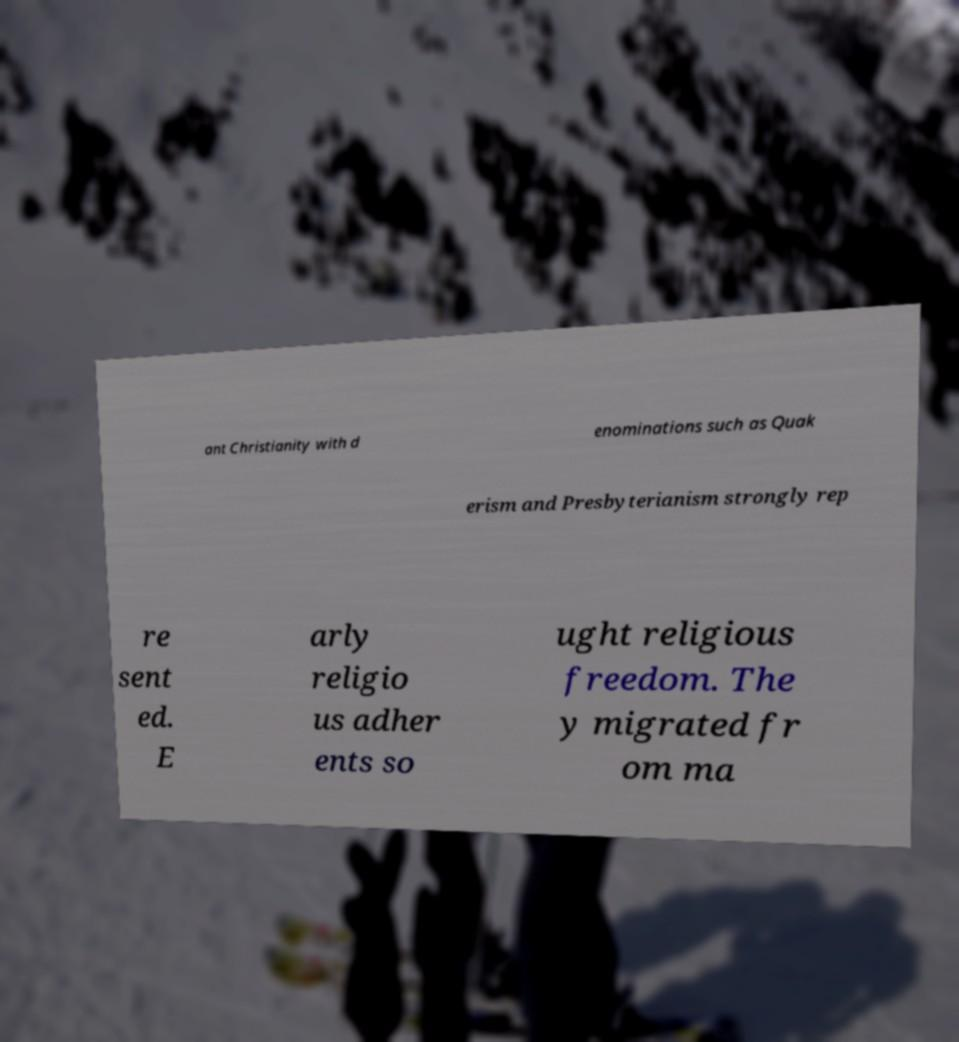What messages or text are displayed in this image? I need them in a readable, typed format. ant Christianity with d enominations such as Quak erism and Presbyterianism strongly rep re sent ed. E arly religio us adher ents so ught religious freedom. The y migrated fr om ma 